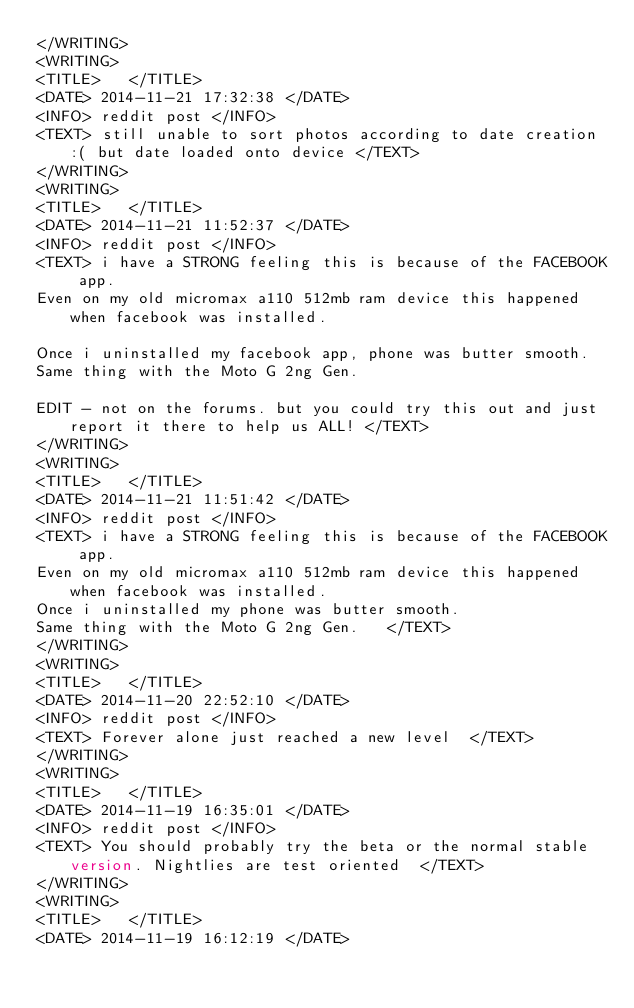Convert code to text. <code><loc_0><loc_0><loc_500><loc_500><_XML_></WRITING>
<WRITING>
<TITLE>   </TITLE>
<DATE> 2014-11-21 17:32:38 </DATE>
<INFO> reddit post </INFO>
<TEXT> still unable to sort photos according to date creation :( but date loaded onto device </TEXT>
</WRITING>
<WRITING>
<TITLE>   </TITLE>
<DATE> 2014-11-21 11:52:37 </DATE>
<INFO> reddit post </INFO>
<TEXT> i have a STRONG feeling this is because of the FACEBOOK app.  
Even on my old micromax a110 512mb ram device this happened when facebook was installed.  

Once i uninstalled my facebook app, phone was butter smooth.  
Same thing with the Moto G 2ng Gen.   

EDIT - not on the forums. but you could try this out and just report it there to help us ALL! </TEXT>
</WRITING>
<WRITING>
<TITLE>   </TITLE>
<DATE> 2014-11-21 11:51:42 </DATE>
<INFO> reddit post </INFO>
<TEXT> i have a STRONG feeling this is because of the FACEBOOK app.  
Even on my old micromax a110 512mb ram device this happened when facebook was installed.  
Once i uninstalled my phone was butter smooth.  
Same thing with the Moto G 2ng Gen.   </TEXT>
</WRITING>
<WRITING>
<TITLE>   </TITLE>
<DATE> 2014-11-20 22:52:10 </DATE>
<INFO> reddit post </INFO>
<TEXT> Forever alone just reached a new level  </TEXT>
</WRITING>
<WRITING>
<TITLE>   </TITLE>
<DATE> 2014-11-19 16:35:01 </DATE>
<INFO> reddit post </INFO>
<TEXT> You should probably try the beta or the normal stable version. Nightlies are test oriented  </TEXT>
</WRITING>
<WRITING>
<TITLE>   </TITLE>
<DATE> 2014-11-19 16:12:19 </DATE></code> 